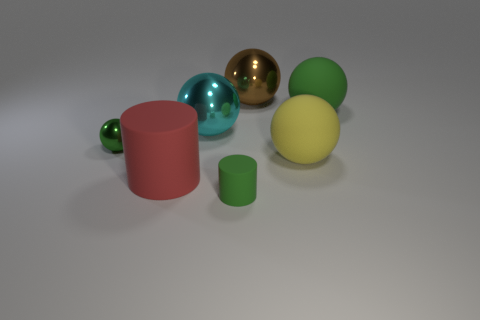Are there fewer things to the left of the large red object than large red objects?
Offer a terse response. No. What number of small objects are green rubber spheres or rubber cylinders?
Your response must be concise. 1. What is the size of the yellow thing?
Provide a short and direct response. Large. There is a tiny green metal thing; how many metallic things are in front of it?
Your answer should be very brief. 0. The brown shiny thing that is the same shape as the big cyan metallic object is what size?
Offer a terse response. Large. There is a green object that is both to the right of the small sphere and in front of the large cyan metal object; how big is it?
Your answer should be very brief. Small. There is a tiny rubber object; is it the same color as the big object that is behind the green rubber sphere?
Offer a terse response. No. What number of green objects are either small objects or cylinders?
Keep it short and to the point. 2. What is the shape of the small matte object?
Provide a short and direct response. Cylinder. What number of other objects are there of the same shape as the cyan object?
Provide a short and direct response. 4. 